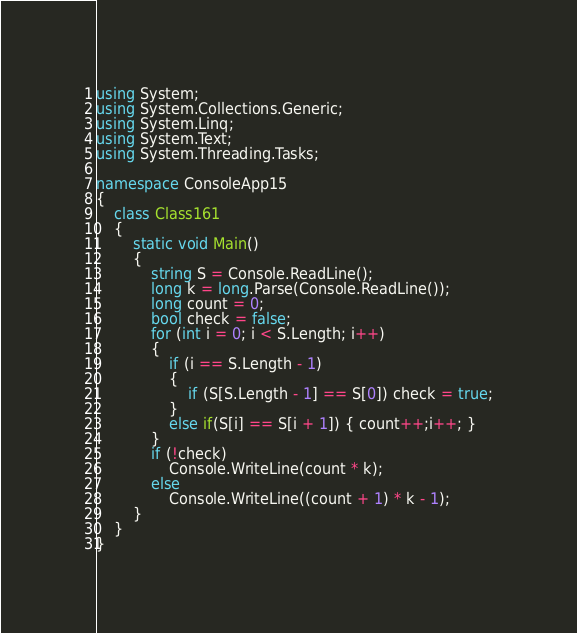<code> <loc_0><loc_0><loc_500><loc_500><_C#_>using System;
using System.Collections.Generic;
using System.Linq;
using System.Text;
using System.Threading.Tasks;

namespace ConsoleApp15
{
    class Class161
    {
        static void Main()
        {
            string S = Console.ReadLine();
            long k = long.Parse(Console.ReadLine());
            long count = 0;
            bool check = false;
            for (int i = 0; i < S.Length; i++)
            {
                if (i == S.Length - 1)
                {
                    if (S[S.Length - 1] == S[0]) check = true;
                }
                else if(S[i] == S[i + 1]) { count++;i++; }
            }
            if (!check)
                Console.WriteLine(count * k);
            else
                Console.WriteLine((count + 1) * k - 1);
        }
    }
}
</code> 